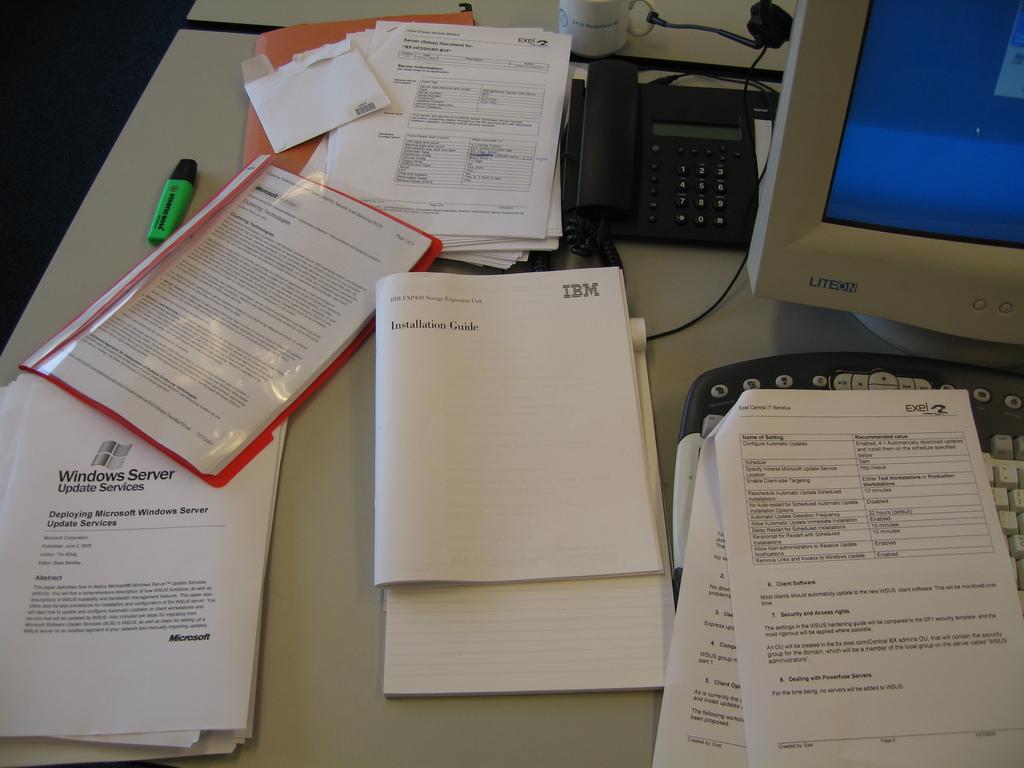What type of guide is shown in the middle?
Offer a terse response. Installation. 